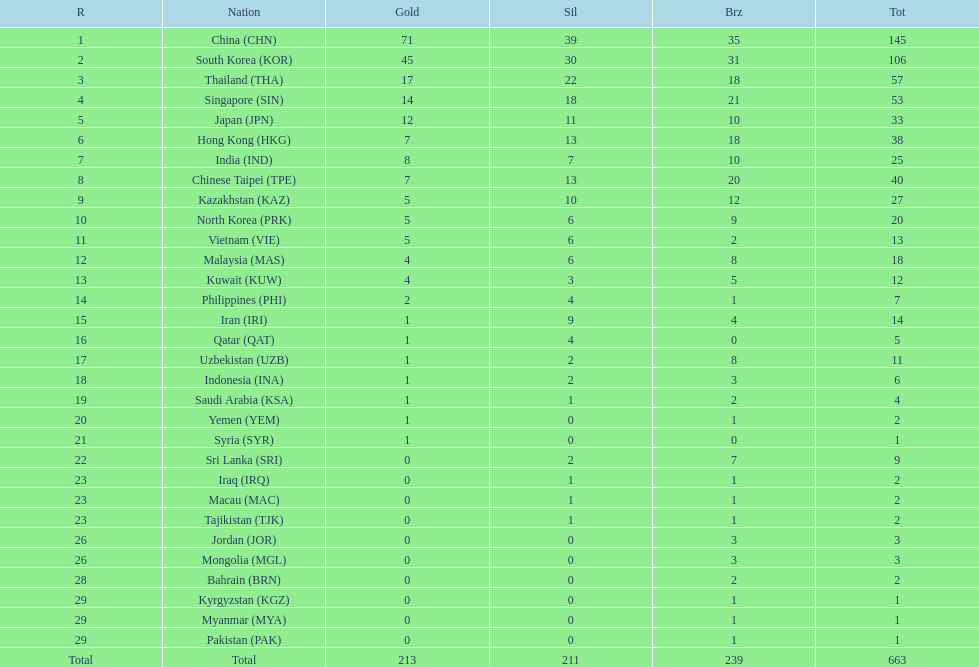What is the total number of medals that india won in the asian youth games? 25. Would you be able to parse every entry in this table? {'header': ['R', 'Nation', 'Gold', 'Sil', 'Brz', 'Tot'], 'rows': [['1', 'China\xa0(CHN)', '71', '39', '35', '145'], ['2', 'South Korea\xa0(KOR)', '45', '30', '31', '106'], ['3', 'Thailand\xa0(THA)', '17', '22', '18', '57'], ['4', 'Singapore\xa0(SIN)', '14', '18', '21', '53'], ['5', 'Japan\xa0(JPN)', '12', '11', '10', '33'], ['6', 'Hong Kong\xa0(HKG)', '7', '13', '18', '38'], ['7', 'India\xa0(IND)', '8', '7', '10', '25'], ['8', 'Chinese Taipei\xa0(TPE)', '7', '13', '20', '40'], ['9', 'Kazakhstan\xa0(KAZ)', '5', '10', '12', '27'], ['10', 'North Korea\xa0(PRK)', '5', '6', '9', '20'], ['11', 'Vietnam\xa0(VIE)', '5', '6', '2', '13'], ['12', 'Malaysia\xa0(MAS)', '4', '6', '8', '18'], ['13', 'Kuwait\xa0(KUW)', '4', '3', '5', '12'], ['14', 'Philippines\xa0(PHI)', '2', '4', '1', '7'], ['15', 'Iran\xa0(IRI)', '1', '9', '4', '14'], ['16', 'Qatar\xa0(QAT)', '1', '4', '0', '5'], ['17', 'Uzbekistan\xa0(UZB)', '1', '2', '8', '11'], ['18', 'Indonesia\xa0(INA)', '1', '2', '3', '6'], ['19', 'Saudi Arabia\xa0(KSA)', '1', '1', '2', '4'], ['20', 'Yemen\xa0(YEM)', '1', '0', '1', '2'], ['21', 'Syria\xa0(SYR)', '1', '0', '0', '1'], ['22', 'Sri Lanka\xa0(SRI)', '0', '2', '7', '9'], ['23', 'Iraq\xa0(IRQ)', '0', '1', '1', '2'], ['23', 'Macau\xa0(MAC)', '0', '1', '1', '2'], ['23', 'Tajikistan\xa0(TJK)', '0', '1', '1', '2'], ['26', 'Jordan\xa0(JOR)', '0', '0', '3', '3'], ['26', 'Mongolia\xa0(MGL)', '0', '0', '3', '3'], ['28', 'Bahrain\xa0(BRN)', '0', '0', '2', '2'], ['29', 'Kyrgyzstan\xa0(KGZ)', '0', '0', '1', '1'], ['29', 'Myanmar\xa0(MYA)', '0', '0', '1', '1'], ['29', 'Pakistan\xa0(PAK)', '0', '0', '1', '1'], ['Total', 'Total', '213', '211', '239', '663']]} 